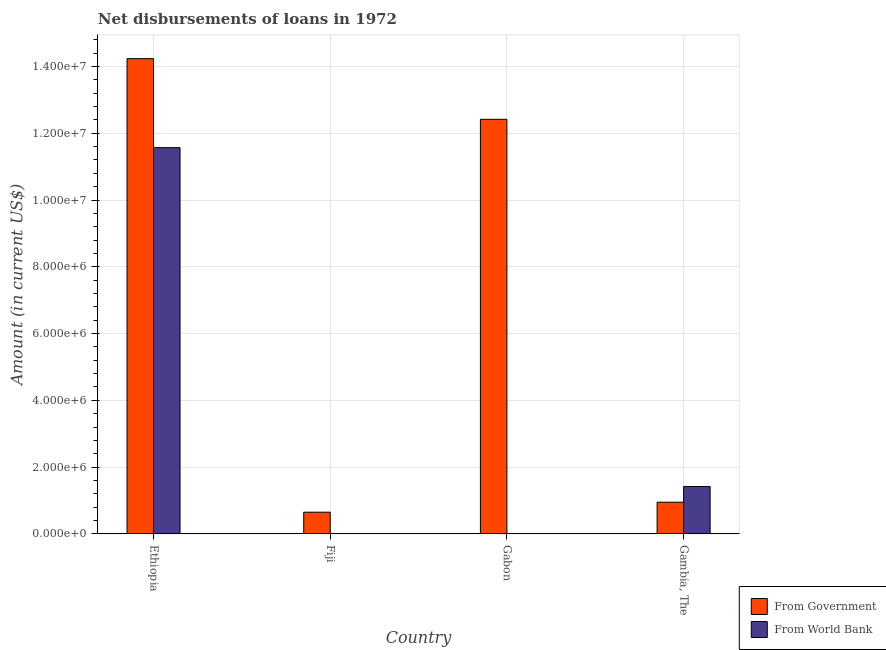How many different coloured bars are there?
Your answer should be very brief. 2. Are the number of bars per tick equal to the number of legend labels?
Keep it short and to the point. No. How many bars are there on the 1st tick from the left?
Ensure brevity in your answer.  2. What is the label of the 3rd group of bars from the left?
Provide a succinct answer. Gabon. What is the net disbursements of loan from world bank in Gabon?
Provide a succinct answer. 0. Across all countries, what is the maximum net disbursements of loan from world bank?
Give a very brief answer. 1.16e+07. Across all countries, what is the minimum net disbursements of loan from government?
Provide a succinct answer. 6.49e+05. In which country was the net disbursements of loan from world bank maximum?
Make the answer very short. Ethiopia. What is the total net disbursements of loan from government in the graph?
Your answer should be compact. 2.83e+07. What is the difference between the net disbursements of loan from government in Fiji and that in Gabon?
Provide a short and direct response. -1.18e+07. What is the difference between the net disbursements of loan from world bank in Fiji and the net disbursements of loan from government in Gambia, The?
Give a very brief answer. -9.39e+05. What is the average net disbursements of loan from government per country?
Your response must be concise. 7.06e+06. What is the difference between the net disbursements of loan from world bank and net disbursements of loan from government in Gambia, The?
Your answer should be very brief. 4.71e+05. What is the ratio of the net disbursements of loan from government in Gabon to that in Gambia, The?
Ensure brevity in your answer.  13.1. What is the difference between the highest and the second highest net disbursements of loan from world bank?
Offer a very short reply. 1.02e+07. What is the difference between the highest and the lowest net disbursements of loan from government?
Your answer should be compact. 1.36e+07. In how many countries, is the net disbursements of loan from world bank greater than the average net disbursements of loan from world bank taken over all countries?
Provide a succinct answer. 1. Are all the bars in the graph horizontal?
Offer a very short reply. No. How many countries are there in the graph?
Provide a short and direct response. 4. Does the graph contain grids?
Ensure brevity in your answer.  Yes. Where does the legend appear in the graph?
Make the answer very short. Bottom right. What is the title of the graph?
Your response must be concise. Net disbursements of loans in 1972. Does "Fertility rate" appear as one of the legend labels in the graph?
Provide a short and direct response. No. What is the label or title of the Y-axis?
Give a very brief answer. Amount (in current US$). What is the Amount (in current US$) of From Government in Ethiopia?
Offer a very short reply. 1.42e+07. What is the Amount (in current US$) of From World Bank in Ethiopia?
Offer a terse response. 1.16e+07. What is the Amount (in current US$) of From Government in Fiji?
Keep it short and to the point. 6.49e+05. What is the Amount (in current US$) of From World Bank in Fiji?
Offer a very short reply. 9000. What is the Amount (in current US$) of From Government in Gabon?
Provide a succinct answer. 1.24e+07. What is the Amount (in current US$) of From World Bank in Gabon?
Provide a short and direct response. 0. What is the Amount (in current US$) in From Government in Gambia, The?
Give a very brief answer. 9.48e+05. What is the Amount (in current US$) in From World Bank in Gambia, The?
Provide a succinct answer. 1.42e+06. Across all countries, what is the maximum Amount (in current US$) of From Government?
Make the answer very short. 1.42e+07. Across all countries, what is the maximum Amount (in current US$) of From World Bank?
Your answer should be very brief. 1.16e+07. Across all countries, what is the minimum Amount (in current US$) of From Government?
Make the answer very short. 6.49e+05. What is the total Amount (in current US$) in From Government in the graph?
Provide a succinct answer. 2.83e+07. What is the total Amount (in current US$) in From World Bank in the graph?
Offer a very short reply. 1.30e+07. What is the difference between the Amount (in current US$) of From Government in Ethiopia and that in Fiji?
Provide a short and direct response. 1.36e+07. What is the difference between the Amount (in current US$) in From World Bank in Ethiopia and that in Fiji?
Your answer should be compact. 1.16e+07. What is the difference between the Amount (in current US$) of From Government in Ethiopia and that in Gabon?
Provide a short and direct response. 1.82e+06. What is the difference between the Amount (in current US$) in From Government in Ethiopia and that in Gambia, The?
Ensure brevity in your answer.  1.33e+07. What is the difference between the Amount (in current US$) in From World Bank in Ethiopia and that in Gambia, The?
Give a very brief answer. 1.02e+07. What is the difference between the Amount (in current US$) in From Government in Fiji and that in Gabon?
Your response must be concise. -1.18e+07. What is the difference between the Amount (in current US$) of From Government in Fiji and that in Gambia, The?
Ensure brevity in your answer.  -2.99e+05. What is the difference between the Amount (in current US$) of From World Bank in Fiji and that in Gambia, The?
Your answer should be very brief. -1.41e+06. What is the difference between the Amount (in current US$) in From Government in Gabon and that in Gambia, The?
Provide a succinct answer. 1.15e+07. What is the difference between the Amount (in current US$) of From Government in Ethiopia and the Amount (in current US$) of From World Bank in Fiji?
Provide a succinct answer. 1.42e+07. What is the difference between the Amount (in current US$) of From Government in Ethiopia and the Amount (in current US$) of From World Bank in Gambia, The?
Your response must be concise. 1.28e+07. What is the difference between the Amount (in current US$) in From Government in Fiji and the Amount (in current US$) in From World Bank in Gambia, The?
Keep it short and to the point. -7.70e+05. What is the difference between the Amount (in current US$) in From Government in Gabon and the Amount (in current US$) in From World Bank in Gambia, The?
Your answer should be compact. 1.10e+07. What is the average Amount (in current US$) of From Government per country?
Your response must be concise. 7.06e+06. What is the average Amount (in current US$) of From World Bank per country?
Offer a terse response. 3.25e+06. What is the difference between the Amount (in current US$) of From Government and Amount (in current US$) of From World Bank in Ethiopia?
Provide a succinct answer. 2.67e+06. What is the difference between the Amount (in current US$) in From Government and Amount (in current US$) in From World Bank in Fiji?
Give a very brief answer. 6.40e+05. What is the difference between the Amount (in current US$) in From Government and Amount (in current US$) in From World Bank in Gambia, The?
Your answer should be compact. -4.71e+05. What is the ratio of the Amount (in current US$) in From Government in Ethiopia to that in Fiji?
Your answer should be very brief. 21.94. What is the ratio of the Amount (in current US$) of From World Bank in Ethiopia to that in Fiji?
Give a very brief answer. 1285.44. What is the ratio of the Amount (in current US$) in From Government in Ethiopia to that in Gabon?
Your answer should be very brief. 1.15. What is the ratio of the Amount (in current US$) of From Government in Ethiopia to that in Gambia, The?
Give a very brief answer. 15.02. What is the ratio of the Amount (in current US$) in From World Bank in Ethiopia to that in Gambia, The?
Your answer should be very brief. 8.15. What is the ratio of the Amount (in current US$) of From Government in Fiji to that in Gabon?
Make the answer very short. 0.05. What is the ratio of the Amount (in current US$) in From Government in Fiji to that in Gambia, The?
Make the answer very short. 0.68. What is the ratio of the Amount (in current US$) in From World Bank in Fiji to that in Gambia, The?
Keep it short and to the point. 0.01. What is the ratio of the Amount (in current US$) in From Government in Gabon to that in Gambia, The?
Ensure brevity in your answer.  13.1. What is the difference between the highest and the second highest Amount (in current US$) in From Government?
Offer a terse response. 1.82e+06. What is the difference between the highest and the second highest Amount (in current US$) of From World Bank?
Make the answer very short. 1.02e+07. What is the difference between the highest and the lowest Amount (in current US$) of From Government?
Offer a very short reply. 1.36e+07. What is the difference between the highest and the lowest Amount (in current US$) of From World Bank?
Ensure brevity in your answer.  1.16e+07. 